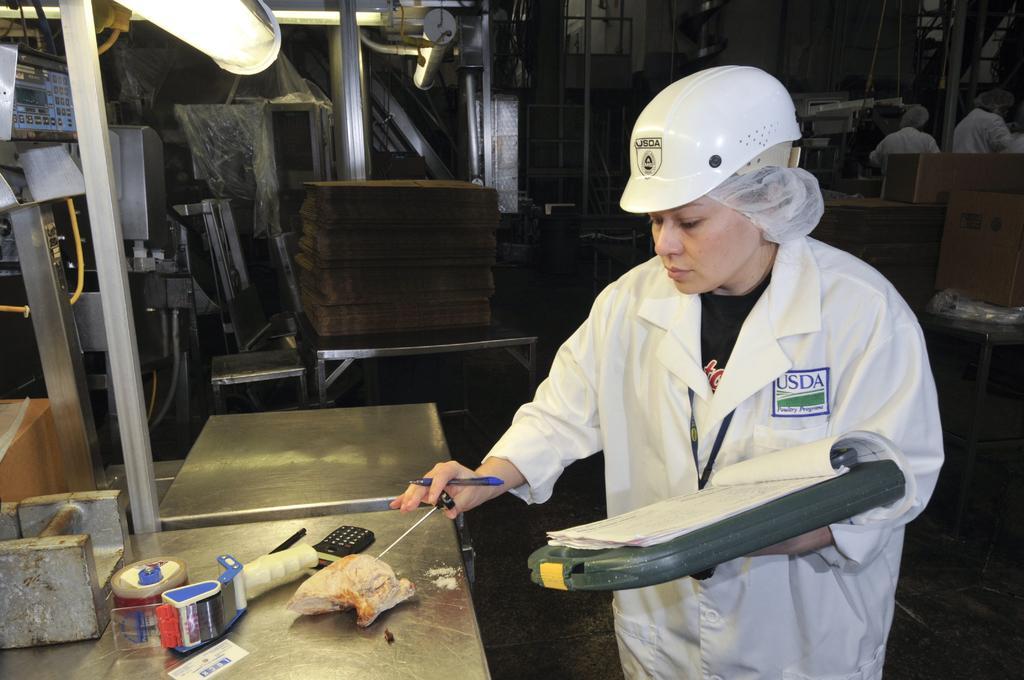Can you describe this image briefly? In this picture there is a man who is wearing helmet, t-shirt, apron and holding the book and pen. She is standing near to the table. On the table I can see the mobile phone, plaster and other objects. In the back I can see the tables and other objects which are placed near to the window and wall. In the top right corner I can see two persons who are standing near to the wall. 